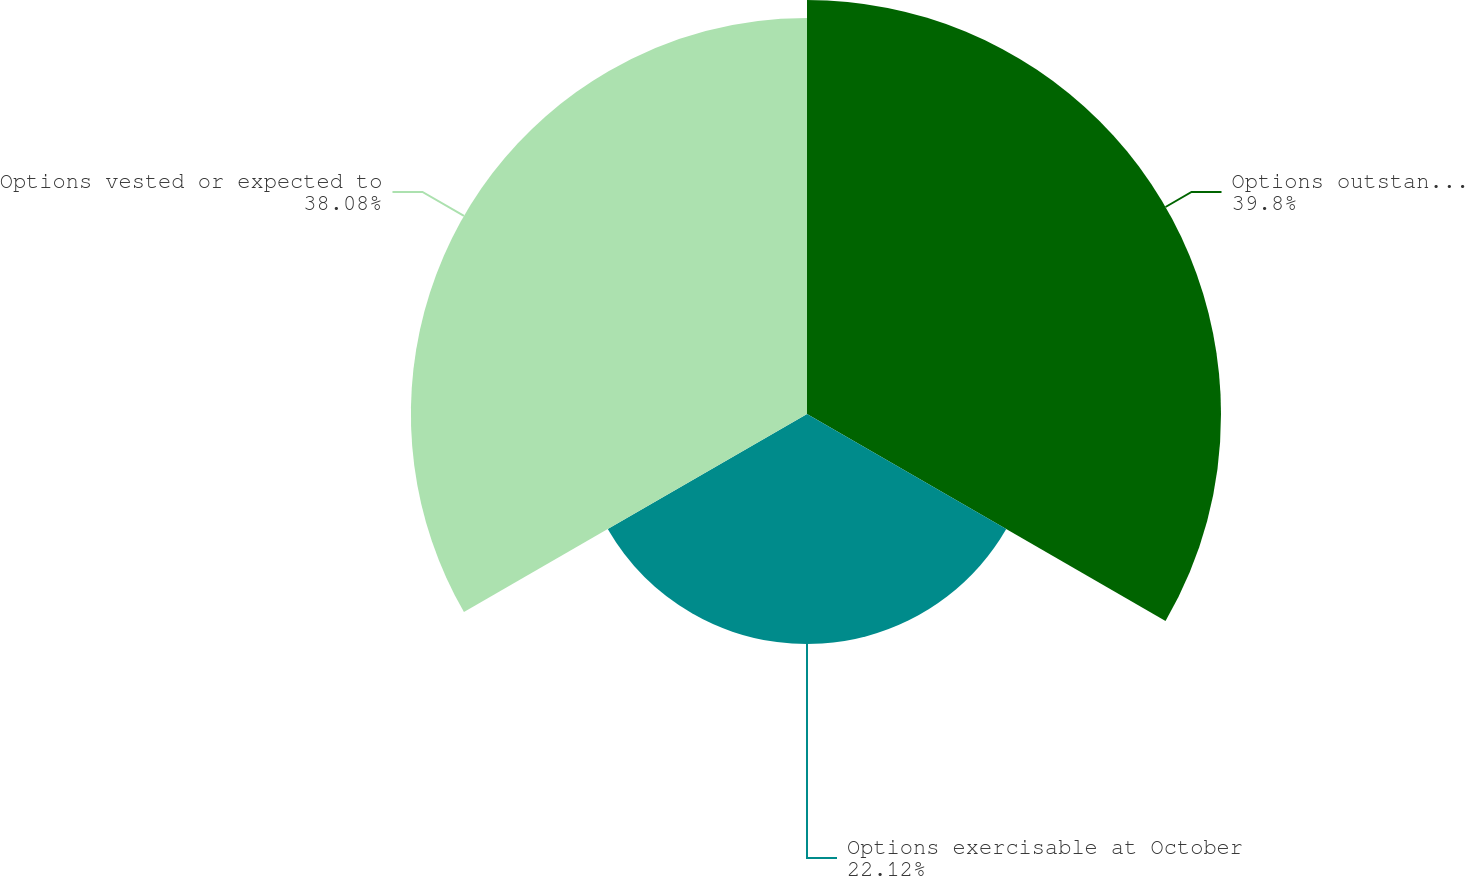<chart> <loc_0><loc_0><loc_500><loc_500><pie_chart><fcel>Options outstanding at October<fcel>Options exercisable at October<fcel>Options vested or expected to<nl><fcel>39.8%<fcel>22.12%<fcel>38.08%<nl></chart> 